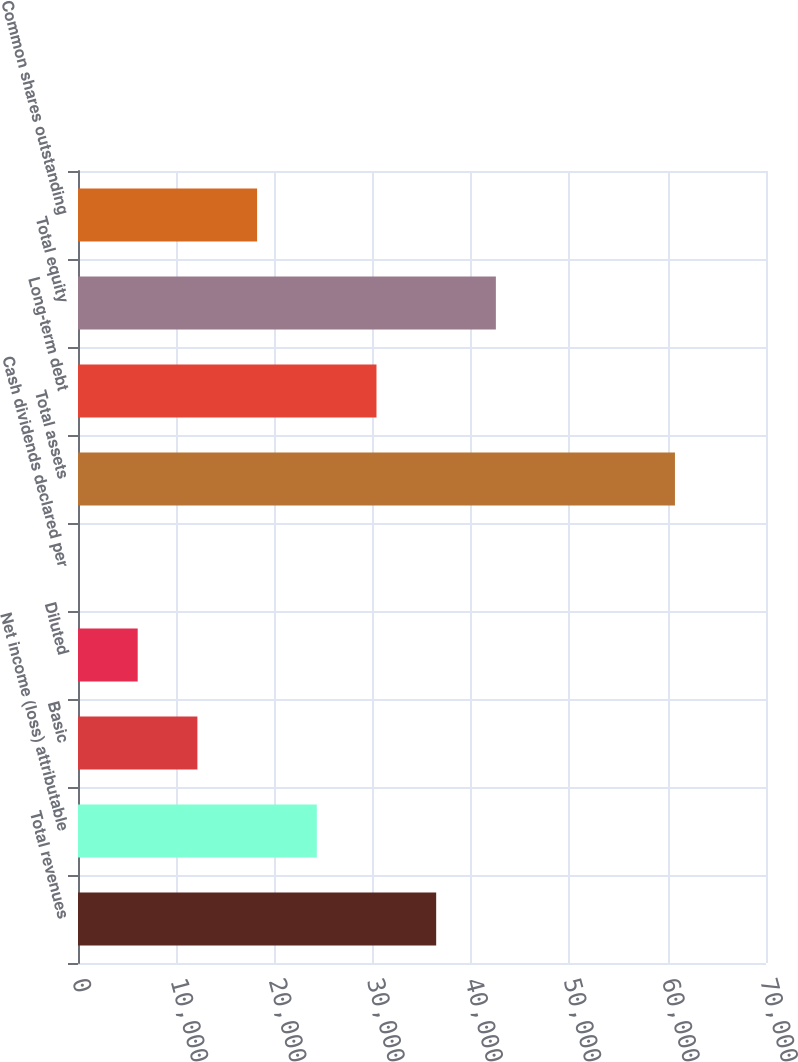Convert chart. <chart><loc_0><loc_0><loc_500><loc_500><bar_chart><fcel>Total revenues<fcel>Net income (loss) attributable<fcel>Basic<fcel>Diluted<fcel>Cash dividends declared per<fcel>Total assets<fcel>Long-term debt<fcel>Total equity<fcel>Common shares outstanding<nl><fcel>36442.5<fcel>24295.2<fcel>12147.9<fcel>6074.31<fcel>0.68<fcel>60737<fcel>30368.8<fcel>42516.1<fcel>18221.6<nl></chart> 